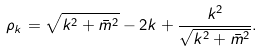<formula> <loc_0><loc_0><loc_500><loc_500>\rho _ { k } = \sqrt { k ^ { 2 } + \bar { m } ^ { 2 } } - 2 k + \frac { k ^ { 2 } } { \sqrt { k ^ { 2 } + \bar { m } ^ { 2 } } } .</formula> 